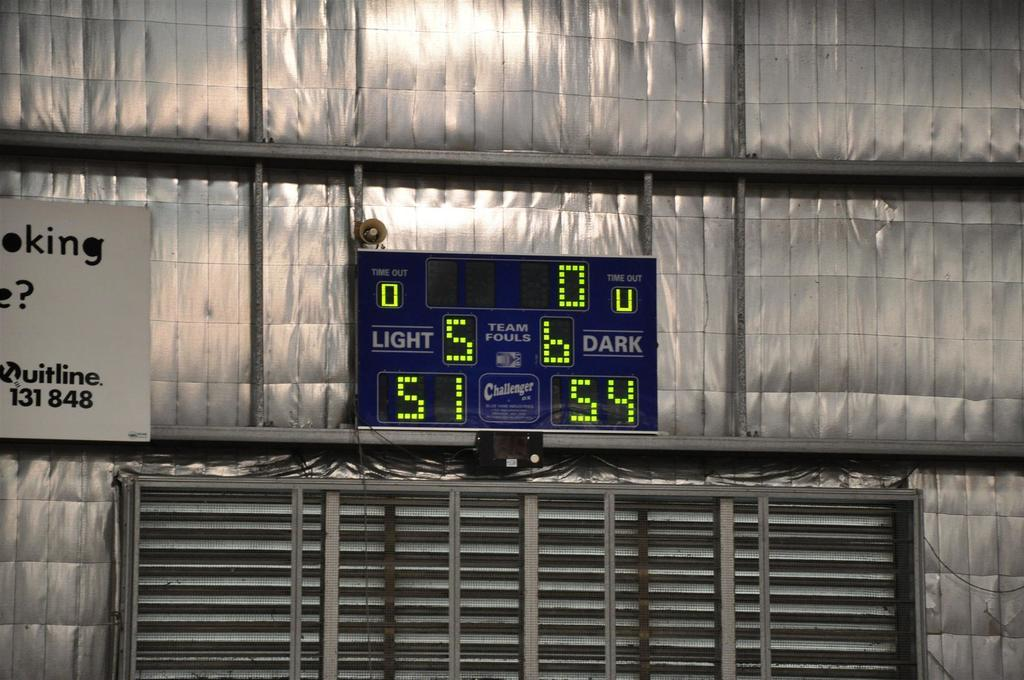<image>
Present a compact description of the photo's key features. A scoreboard shows the score of teams as 51 and 54. 